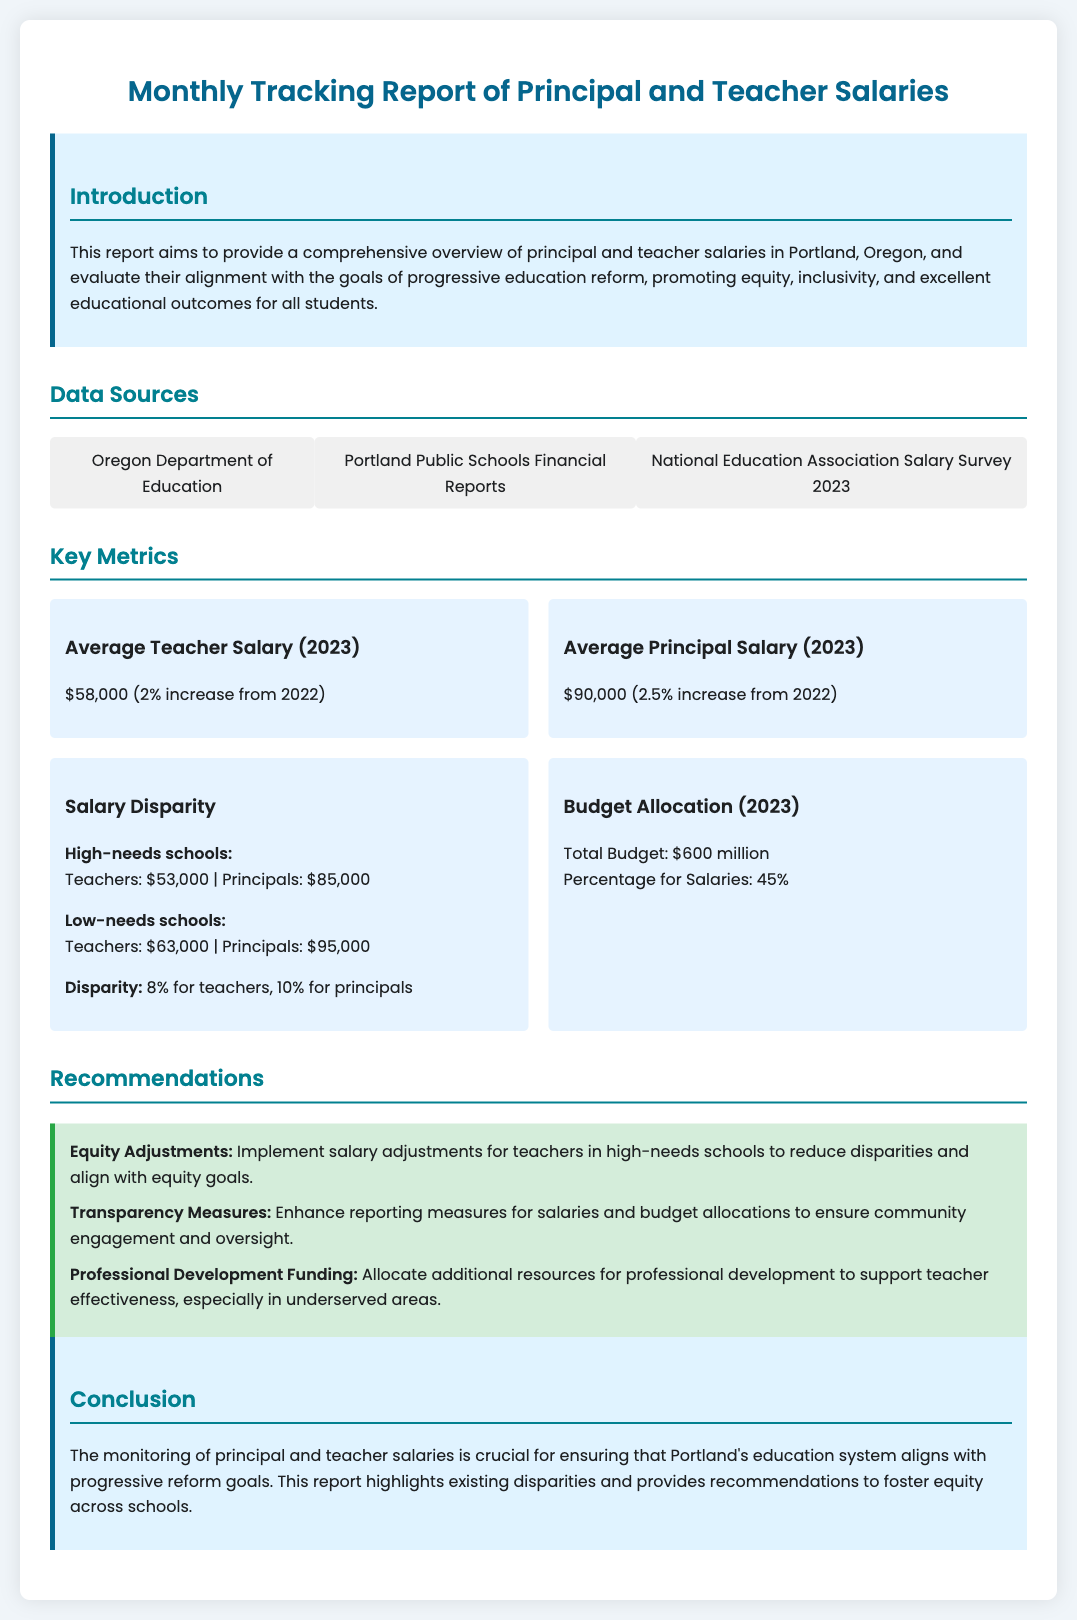What is the average teacher salary in 2023? The document states that the average teacher salary in 2023 is $58,000.
Answer: $58,000 What is the average principal salary in 2023? According to the document, the average principal salary in 2023 is $90,000.
Answer: $90,000 What is the salary disparity for high-needs schools? The document specifies that the salary disparity for high-needs schools is 8% for teachers and 10% for principals.
Answer: 8% for teachers, 10% for principals What is the total budget allocated for salaries in 2023? The document mentions that the total budget is $600 million, and the percentage allocated for salaries is 45%.
Answer: 45% What recommendation is made for equity adjustments? The report recommends implementing salary adjustments for teachers in high-needs schools to reduce disparities.
Answer: Salary adjustments for teachers What is the total budget amount? The total budget amount reported is $600 million.
Answer: $600 million What are the three data sources listed? The document lists the Oregon Department of Education, Portland Public Schools Financial Reports, and the National Education Association Salary Survey 2023 as data sources.
Answer: Oregon Department of Education, Portland Public Schools Financial Reports, National Education Association Salary Survey 2023 What main theme does this report aim to address? The report aims to evaluate principal and teacher salaries' alignment with equity, inclusivity, and educational outcomes.
Answer: Equity and inclusivity What percentage of the budget is allocated to salaries? The document states that 45% of the total budget is allocated to salaries.
Answer: 45% 